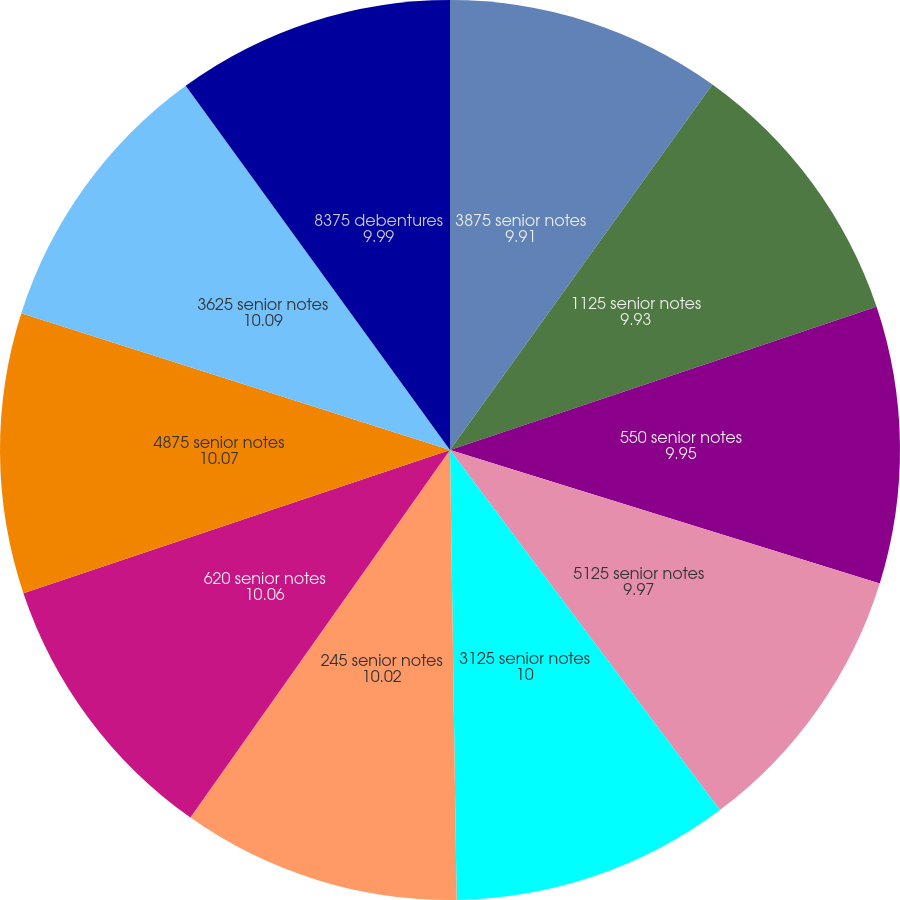<chart> <loc_0><loc_0><loc_500><loc_500><pie_chart><fcel>3875 senior notes<fcel>1125 senior notes<fcel>550 senior notes<fcel>5125 senior notes<fcel>3125 senior notes<fcel>245 senior notes<fcel>620 senior notes<fcel>4875 senior notes<fcel>3625 senior notes<fcel>8375 debentures<nl><fcel>9.91%<fcel>9.93%<fcel>9.95%<fcel>9.97%<fcel>10.0%<fcel>10.02%<fcel>10.06%<fcel>10.07%<fcel>10.09%<fcel>9.99%<nl></chart> 